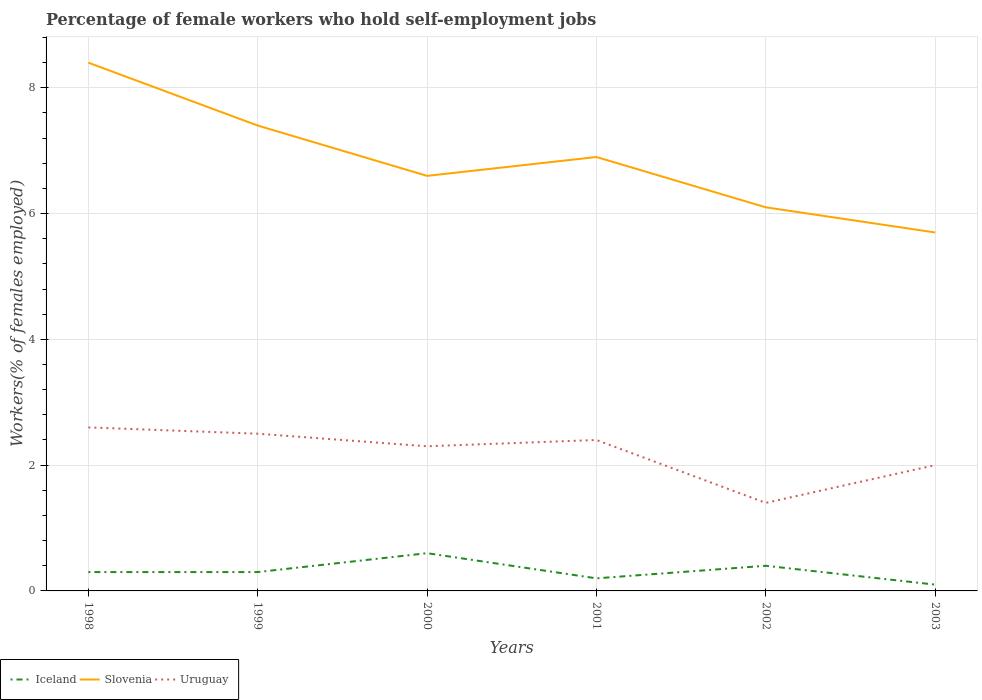Does the line corresponding to Uruguay intersect with the line corresponding to Iceland?
Offer a very short reply. No. Across all years, what is the maximum percentage of self-employed female workers in Slovenia?
Give a very brief answer. 5.7. In which year was the percentage of self-employed female workers in Slovenia maximum?
Ensure brevity in your answer.  2003. What is the total percentage of self-employed female workers in Iceland in the graph?
Offer a terse response. 0. What is the difference between the highest and the second highest percentage of self-employed female workers in Uruguay?
Keep it short and to the point. 1.2. Is the percentage of self-employed female workers in Iceland strictly greater than the percentage of self-employed female workers in Uruguay over the years?
Ensure brevity in your answer.  Yes. How many lines are there?
Make the answer very short. 3. How many years are there in the graph?
Your answer should be very brief. 6. How many legend labels are there?
Ensure brevity in your answer.  3. How are the legend labels stacked?
Offer a terse response. Horizontal. What is the title of the graph?
Your response must be concise. Percentage of female workers who hold self-employment jobs. What is the label or title of the X-axis?
Your answer should be very brief. Years. What is the label or title of the Y-axis?
Keep it short and to the point. Workers(% of females employed). What is the Workers(% of females employed) of Iceland in 1998?
Make the answer very short. 0.3. What is the Workers(% of females employed) of Slovenia in 1998?
Provide a succinct answer. 8.4. What is the Workers(% of females employed) of Uruguay in 1998?
Keep it short and to the point. 2.6. What is the Workers(% of females employed) in Iceland in 1999?
Your response must be concise. 0.3. What is the Workers(% of females employed) in Slovenia in 1999?
Your answer should be compact. 7.4. What is the Workers(% of females employed) of Uruguay in 1999?
Offer a terse response. 2.5. What is the Workers(% of females employed) in Iceland in 2000?
Ensure brevity in your answer.  0.6. What is the Workers(% of females employed) in Slovenia in 2000?
Give a very brief answer. 6.6. What is the Workers(% of females employed) of Uruguay in 2000?
Ensure brevity in your answer.  2.3. What is the Workers(% of females employed) of Iceland in 2001?
Your answer should be very brief. 0.2. What is the Workers(% of females employed) in Slovenia in 2001?
Your response must be concise. 6.9. What is the Workers(% of females employed) in Uruguay in 2001?
Make the answer very short. 2.4. What is the Workers(% of females employed) of Iceland in 2002?
Give a very brief answer. 0.4. What is the Workers(% of females employed) in Slovenia in 2002?
Keep it short and to the point. 6.1. What is the Workers(% of females employed) in Uruguay in 2002?
Make the answer very short. 1.4. What is the Workers(% of females employed) in Iceland in 2003?
Provide a short and direct response. 0.1. What is the Workers(% of females employed) of Slovenia in 2003?
Give a very brief answer. 5.7. What is the Workers(% of females employed) in Uruguay in 2003?
Your response must be concise. 2. Across all years, what is the maximum Workers(% of females employed) of Iceland?
Provide a short and direct response. 0.6. Across all years, what is the maximum Workers(% of females employed) of Slovenia?
Your answer should be very brief. 8.4. Across all years, what is the maximum Workers(% of females employed) in Uruguay?
Offer a very short reply. 2.6. Across all years, what is the minimum Workers(% of females employed) of Iceland?
Keep it short and to the point. 0.1. Across all years, what is the minimum Workers(% of females employed) in Slovenia?
Offer a terse response. 5.7. Across all years, what is the minimum Workers(% of females employed) in Uruguay?
Your response must be concise. 1.4. What is the total Workers(% of females employed) of Slovenia in the graph?
Your answer should be very brief. 41.1. What is the total Workers(% of females employed) in Uruguay in the graph?
Keep it short and to the point. 13.2. What is the difference between the Workers(% of females employed) of Slovenia in 1998 and that in 2000?
Make the answer very short. 1.8. What is the difference between the Workers(% of females employed) of Iceland in 1998 and that in 2002?
Your response must be concise. -0.1. What is the difference between the Workers(% of females employed) of Uruguay in 1998 and that in 2002?
Your response must be concise. 1.2. What is the difference between the Workers(% of females employed) of Iceland in 1998 and that in 2003?
Offer a terse response. 0.2. What is the difference between the Workers(% of females employed) of Uruguay in 1998 and that in 2003?
Offer a terse response. 0.6. What is the difference between the Workers(% of females employed) of Iceland in 1999 and that in 2000?
Offer a very short reply. -0.3. What is the difference between the Workers(% of females employed) in Slovenia in 1999 and that in 2000?
Give a very brief answer. 0.8. What is the difference between the Workers(% of females employed) of Iceland in 1999 and that in 2001?
Make the answer very short. 0.1. What is the difference between the Workers(% of females employed) in Iceland in 1999 and that in 2003?
Make the answer very short. 0.2. What is the difference between the Workers(% of females employed) in Slovenia in 1999 and that in 2003?
Keep it short and to the point. 1.7. What is the difference between the Workers(% of females employed) in Iceland in 2000 and that in 2001?
Your answer should be very brief. 0.4. What is the difference between the Workers(% of females employed) in Iceland in 2000 and that in 2002?
Offer a very short reply. 0.2. What is the difference between the Workers(% of females employed) of Slovenia in 2000 and that in 2003?
Your response must be concise. 0.9. What is the difference between the Workers(% of females employed) in Slovenia in 2001 and that in 2002?
Give a very brief answer. 0.8. What is the difference between the Workers(% of females employed) of Uruguay in 2001 and that in 2003?
Make the answer very short. 0.4. What is the difference between the Workers(% of females employed) in Slovenia in 2002 and that in 2003?
Make the answer very short. 0.4. What is the difference between the Workers(% of females employed) in Uruguay in 2002 and that in 2003?
Your answer should be very brief. -0.6. What is the difference between the Workers(% of females employed) of Iceland in 1998 and the Workers(% of females employed) of Slovenia in 2000?
Ensure brevity in your answer.  -6.3. What is the difference between the Workers(% of females employed) in Iceland in 1998 and the Workers(% of females employed) in Uruguay in 2000?
Provide a short and direct response. -2. What is the difference between the Workers(% of females employed) of Slovenia in 1998 and the Workers(% of females employed) of Uruguay in 2000?
Provide a succinct answer. 6.1. What is the difference between the Workers(% of females employed) of Slovenia in 1998 and the Workers(% of females employed) of Uruguay in 2001?
Offer a terse response. 6. What is the difference between the Workers(% of females employed) in Iceland in 1999 and the Workers(% of females employed) in Slovenia in 2000?
Ensure brevity in your answer.  -6.3. What is the difference between the Workers(% of females employed) of Iceland in 1999 and the Workers(% of females employed) of Slovenia in 2001?
Give a very brief answer. -6.6. What is the difference between the Workers(% of females employed) in Slovenia in 1999 and the Workers(% of females employed) in Uruguay in 2001?
Ensure brevity in your answer.  5. What is the difference between the Workers(% of females employed) in Iceland in 1999 and the Workers(% of females employed) in Slovenia in 2002?
Your answer should be very brief. -5.8. What is the difference between the Workers(% of females employed) in Slovenia in 1999 and the Workers(% of females employed) in Uruguay in 2002?
Offer a very short reply. 6. What is the difference between the Workers(% of females employed) of Iceland in 1999 and the Workers(% of females employed) of Slovenia in 2003?
Your answer should be very brief. -5.4. What is the difference between the Workers(% of females employed) of Iceland in 2000 and the Workers(% of females employed) of Uruguay in 2002?
Your answer should be compact. -0.8. What is the difference between the Workers(% of females employed) of Slovenia in 2000 and the Workers(% of females employed) of Uruguay in 2002?
Your answer should be very brief. 5.2. What is the difference between the Workers(% of females employed) in Iceland in 2000 and the Workers(% of females employed) in Uruguay in 2003?
Offer a terse response. -1.4. What is the difference between the Workers(% of females employed) of Slovenia in 2001 and the Workers(% of females employed) of Uruguay in 2002?
Your response must be concise. 5.5. What is the difference between the Workers(% of females employed) in Iceland in 2002 and the Workers(% of females employed) in Slovenia in 2003?
Give a very brief answer. -5.3. What is the average Workers(% of females employed) in Iceland per year?
Keep it short and to the point. 0.32. What is the average Workers(% of females employed) of Slovenia per year?
Your answer should be compact. 6.85. What is the average Workers(% of females employed) of Uruguay per year?
Keep it short and to the point. 2.2. In the year 1998, what is the difference between the Workers(% of females employed) in Iceland and Workers(% of females employed) in Slovenia?
Offer a very short reply. -8.1. In the year 1999, what is the difference between the Workers(% of females employed) of Iceland and Workers(% of females employed) of Slovenia?
Offer a very short reply. -7.1. In the year 2000, what is the difference between the Workers(% of females employed) of Iceland and Workers(% of females employed) of Uruguay?
Provide a short and direct response. -1.7. In the year 2000, what is the difference between the Workers(% of females employed) in Slovenia and Workers(% of females employed) in Uruguay?
Make the answer very short. 4.3. In the year 2001, what is the difference between the Workers(% of females employed) in Iceland and Workers(% of females employed) in Slovenia?
Give a very brief answer. -6.7. In the year 2001, what is the difference between the Workers(% of females employed) in Iceland and Workers(% of females employed) in Uruguay?
Ensure brevity in your answer.  -2.2. In the year 2001, what is the difference between the Workers(% of females employed) of Slovenia and Workers(% of females employed) of Uruguay?
Offer a very short reply. 4.5. In the year 2002, what is the difference between the Workers(% of females employed) of Iceland and Workers(% of females employed) of Uruguay?
Your answer should be very brief. -1. In the year 2003, what is the difference between the Workers(% of females employed) in Iceland and Workers(% of females employed) in Uruguay?
Offer a terse response. -1.9. In the year 2003, what is the difference between the Workers(% of females employed) in Slovenia and Workers(% of females employed) in Uruguay?
Your answer should be very brief. 3.7. What is the ratio of the Workers(% of females employed) in Slovenia in 1998 to that in 1999?
Your answer should be very brief. 1.14. What is the ratio of the Workers(% of females employed) in Uruguay in 1998 to that in 1999?
Your answer should be compact. 1.04. What is the ratio of the Workers(% of females employed) of Slovenia in 1998 to that in 2000?
Offer a terse response. 1.27. What is the ratio of the Workers(% of females employed) of Uruguay in 1998 to that in 2000?
Give a very brief answer. 1.13. What is the ratio of the Workers(% of females employed) in Iceland in 1998 to that in 2001?
Provide a short and direct response. 1.5. What is the ratio of the Workers(% of females employed) in Slovenia in 1998 to that in 2001?
Give a very brief answer. 1.22. What is the ratio of the Workers(% of females employed) in Uruguay in 1998 to that in 2001?
Offer a terse response. 1.08. What is the ratio of the Workers(% of females employed) of Slovenia in 1998 to that in 2002?
Your answer should be compact. 1.38. What is the ratio of the Workers(% of females employed) of Uruguay in 1998 to that in 2002?
Provide a succinct answer. 1.86. What is the ratio of the Workers(% of females employed) of Iceland in 1998 to that in 2003?
Make the answer very short. 3. What is the ratio of the Workers(% of females employed) in Slovenia in 1998 to that in 2003?
Make the answer very short. 1.47. What is the ratio of the Workers(% of females employed) of Iceland in 1999 to that in 2000?
Your answer should be very brief. 0.5. What is the ratio of the Workers(% of females employed) of Slovenia in 1999 to that in 2000?
Provide a short and direct response. 1.12. What is the ratio of the Workers(% of females employed) of Uruguay in 1999 to that in 2000?
Provide a succinct answer. 1.09. What is the ratio of the Workers(% of females employed) of Slovenia in 1999 to that in 2001?
Your answer should be very brief. 1.07. What is the ratio of the Workers(% of females employed) of Uruguay in 1999 to that in 2001?
Your answer should be compact. 1.04. What is the ratio of the Workers(% of females employed) of Iceland in 1999 to that in 2002?
Your answer should be compact. 0.75. What is the ratio of the Workers(% of females employed) in Slovenia in 1999 to that in 2002?
Offer a very short reply. 1.21. What is the ratio of the Workers(% of females employed) of Uruguay in 1999 to that in 2002?
Offer a very short reply. 1.79. What is the ratio of the Workers(% of females employed) in Iceland in 1999 to that in 2003?
Provide a short and direct response. 3. What is the ratio of the Workers(% of females employed) of Slovenia in 1999 to that in 2003?
Give a very brief answer. 1.3. What is the ratio of the Workers(% of females employed) of Uruguay in 1999 to that in 2003?
Provide a short and direct response. 1.25. What is the ratio of the Workers(% of females employed) of Slovenia in 2000 to that in 2001?
Your answer should be very brief. 0.96. What is the ratio of the Workers(% of females employed) in Iceland in 2000 to that in 2002?
Your answer should be very brief. 1.5. What is the ratio of the Workers(% of females employed) of Slovenia in 2000 to that in 2002?
Keep it short and to the point. 1.08. What is the ratio of the Workers(% of females employed) in Uruguay in 2000 to that in 2002?
Ensure brevity in your answer.  1.64. What is the ratio of the Workers(% of females employed) of Iceland in 2000 to that in 2003?
Your response must be concise. 6. What is the ratio of the Workers(% of females employed) in Slovenia in 2000 to that in 2003?
Keep it short and to the point. 1.16. What is the ratio of the Workers(% of females employed) in Uruguay in 2000 to that in 2003?
Ensure brevity in your answer.  1.15. What is the ratio of the Workers(% of females employed) of Iceland in 2001 to that in 2002?
Provide a short and direct response. 0.5. What is the ratio of the Workers(% of females employed) in Slovenia in 2001 to that in 2002?
Provide a succinct answer. 1.13. What is the ratio of the Workers(% of females employed) of Uruguay in 2001 to that in 2002?
Offer a very short reply. 1.71. What is the ratio of the Workers(% of females employed) of Slovenia in 2001 to that in 2003?
Offer a very short reply. 1.21. What is the ratio of the Workers(% of females employed) of Iceland in 2002 to that in 2003?
Provide a short and direct response. 4. What is the ratio of the Workers(% of females employed) in Slovenia in 2002 to that in 2003?
Provide a short and direct response. 1.07. What is the difference between the highest and the second highest Workers(% of females employed) of Iceland?
Keep it short and to the point. 0.2. What is the difference between the highest and the second highest Workers(% of females employed) of Slovenia?
Keep it short and to the point. 1. What is the difference between the highest and the second highest Workers(% of females employed) of Uruguay?
Your response must be concise. 0.1. What is the difference between the highest and the lowest Workers(% of females employed) in Iceland?
Provide a succinct answer. 0.5. What is the difference between the highest and the lowest Workers(% of females employed) in Uruguay?
Ensure brevity in your answer.  1.2. 